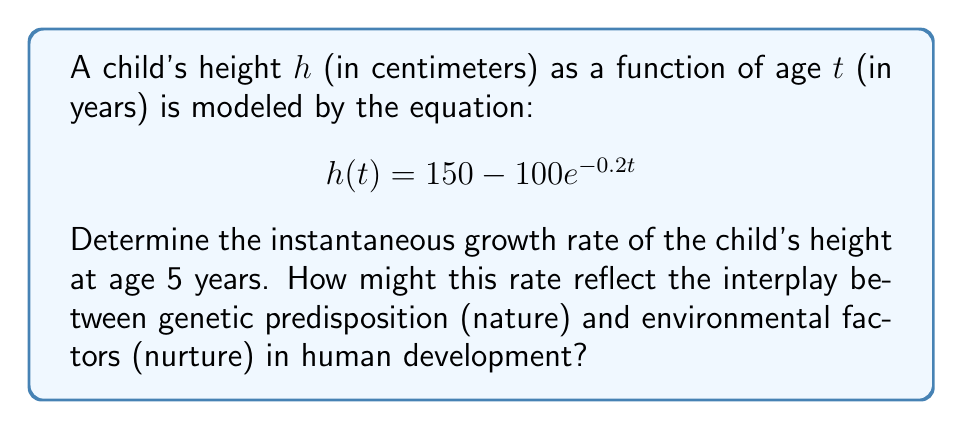Can you answer this question? To find the instantaneous growth rate at age 5, we need to calculate the derivative of the height function $h(t)$ and evaluate it at $t=5$. This represents the rate of change of height with respect to time at that specific age.

Step 1: Calculate the derivative of $h(t)$
$$\frac{d}{dt}h(t) = \frac{d}{dt}(150 - 100e^{-0.2t})$$
$$h'(t) = 0 - 100 \cdot (-0.2e^{-0.2t})$$
$$h'(t) = 20e^{-0.2t}$$

Step 2: Evaluate $h'(t)$ at $t=5$
$$h'(5) = 20e^{-0.2(5)}$$
$$h'(5) = 20e^{-1}$$
$$h'(5) = 20 \cdot 0.3679$$
$$h'(5) \approx 7.358$$

The instantaneous growth rate at age 5 is approximately 7.358 cm/year.

This rate reflects the interplay between nature and nurture in human development:

1. Nature (genetic factors): The basic growth pattern and potential are determined by genes, which influence the overall shape of the growth curve.

2. Nurture (environmental factors): The actual growth rate at any given time can be affected by nutrition, physical activity, and other environmental factors, which can accelerate or decelerate growth within the genetic potential.

The exponential model used here captures both aspects: the genetic potential (asymptotic height of 150 cm) and the environmental influences that modulate the rate of approach to this potential.
Answer: $7.358$ cm/year 